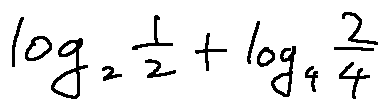<formula> <loc_0><loc_0><loc_500><loc_500>\log _ { 2 } \frac { 1 } { 2 } + \log _ { 4 } \frac { 2 } { 4 }</formula> 